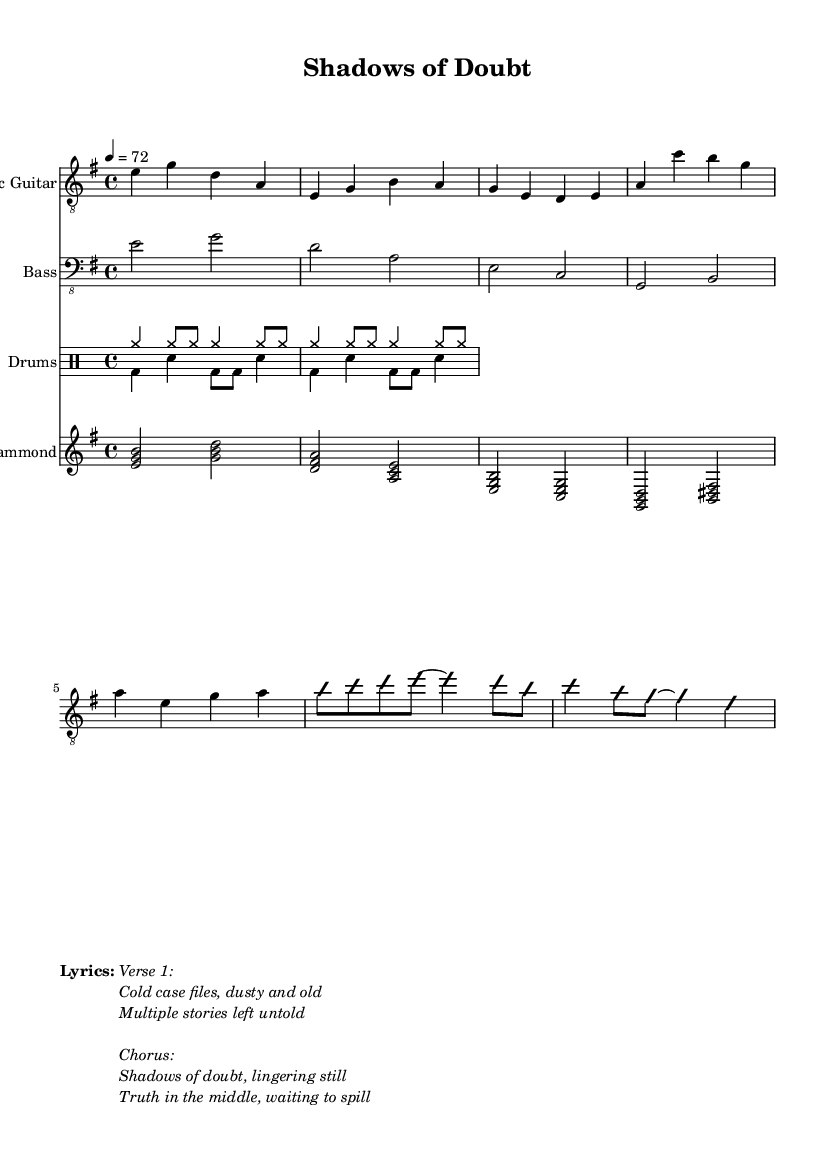What is the key signature of this music? The key signature is E minor, which has one sharp (F#). This is determined by observing the key signature indicated at the beginning of the music.
Answer: E minor What is the time signature of this piece? The time signature is 4/4, meaning there are four beats per measure and the quarter note gets one beat. This can be seen at the start of the music just following the key signature.
Answer: 4/4 What is the tempo marking for this composition? The tempo marking is quarter note = 72 beats per minute, which indicates the speed of the piece. This is typically seen just above the time signature.
Answer: 72 How many measures are in the Intro section? The Intro section contains 2 measures, which can be counted from the music notation showing the electric guitar part. Each measure is separated by a vertical line.
Answer: 2 What instrument plays the basic rock pattern? The drums play the basic rock pattern, which is evident by the drum notation below the other instruments indicated in the music sheet.
Answer: Drums What type of chord progression is used in the Hammond section? The chord progression used in the Hammond section includes major chords, specifically E minor, G major, D major, and A major chords, as indicated in the notation written for the Hammond organ.
Answer: Major chords What is the main theme of the lyrics? The main theme of the lyrics revolves around cold cases and unresolved stories, as indicated in the verses and chorus presented under the music.
Answer: Cold cases 